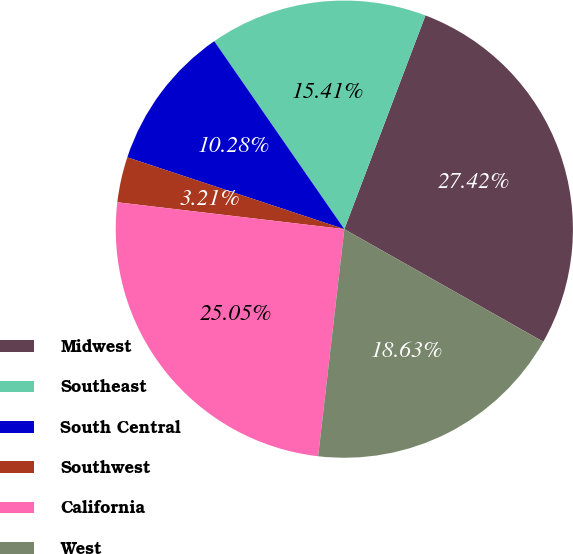<chart> <loc_0><loc_0><loc_500><loc_500><pie_chart><fcel>Midwest<fcel>Southeast<fcel>South Central<fcel>Southwest<fcel>California<fcel>West<nl><fcel>27.42%<fcel>15.41%<fcel>10.28%<fcel>3.21%<fcel>25.05%<fcel>18.63%<nl></chart> 